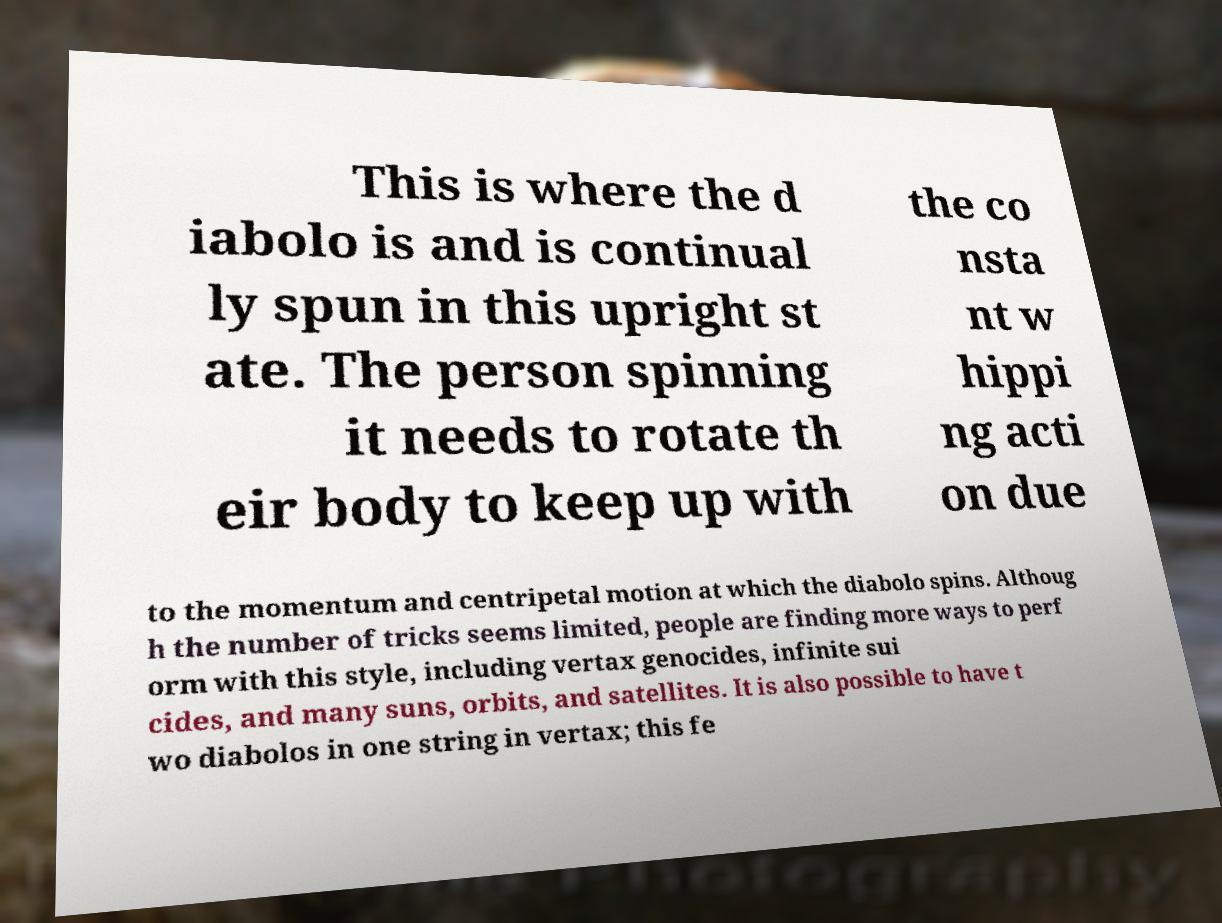There's text embedded in this image that I need extracted. Can you transcribe it verbatim? This is where the d iabolo is and is continual ly spun in this upright st ate. The person spinning it needs to rotate th eir body to keep up with the co nsta nt w hippi ng acti on due to the momentum and centripetal motion at which the diabolo spins. Althoug h the number of tricks seems limited, people are finding more ways to perf orm with this style, including vertax genocides, infinite sui cides, and many suns, orbits, and satellites. It is also possible to have t wo diabolos in one string in vertax; this fe 